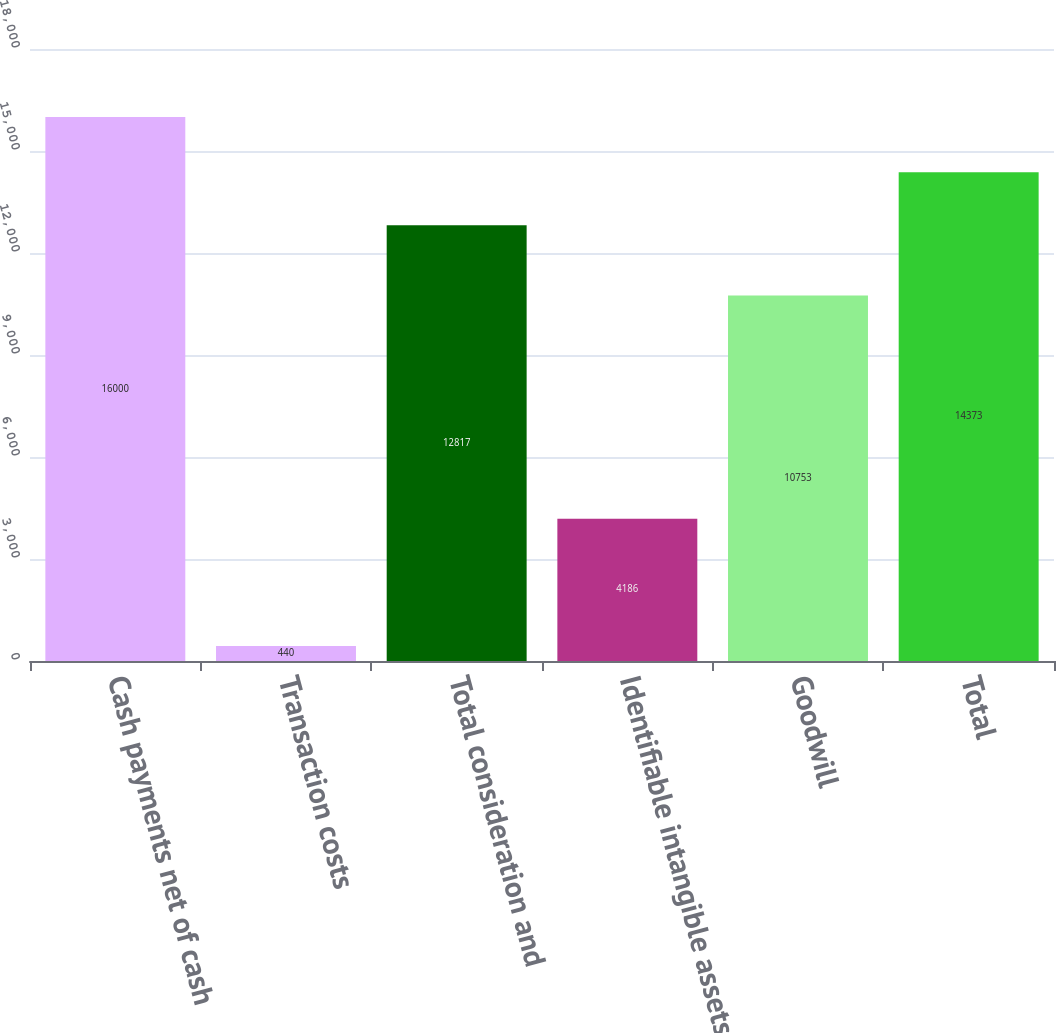<chart> <loc_0><loc_0><loc_500><loc_500><bar_chart><fcel>Cash payments net of cash<fcel>Transaction costs<fcel>Total consideration and<fcel>Identifiable intangible assets<fcel>Goodwill<fcel>Total<nl><fcel>16000<fcel>440<fcel>12817<fcel>4186<fcel>10753<fcel>14373<nl></chart> 